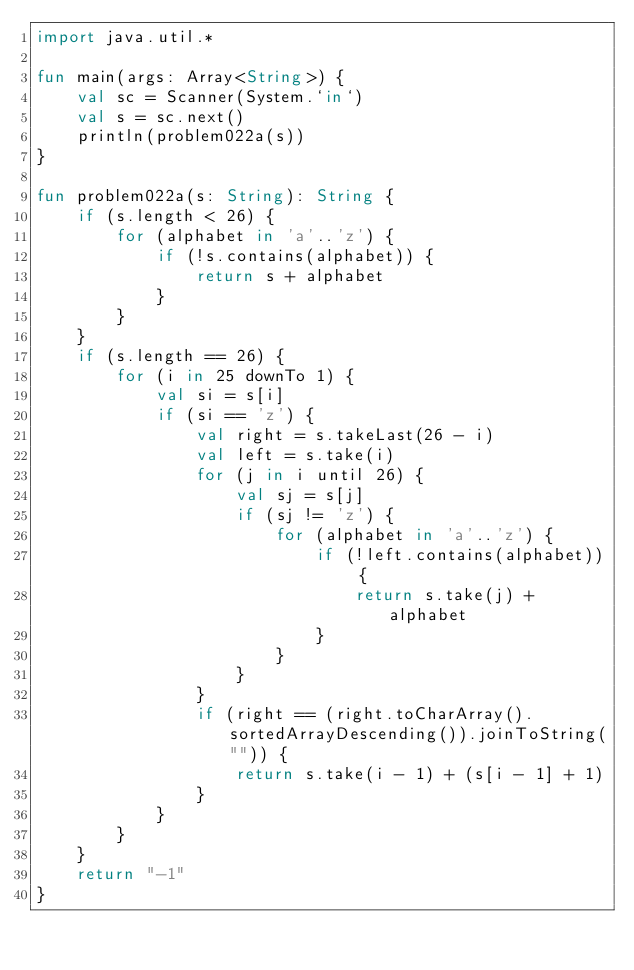<code> <loc_0><loc_0><loc_500><loc_500><_Kotlin_>import java.util.*

fun main(args: Array<String>) {
    val sc = Scanner(System.`in`)
    val s = sc.next()
    println(problem022a(s))
}

fun problem022a(s: String): String {
    if (s.length < 26) {
        for (alphabet in 'a'..'z') {
            if (!s.contains(alphabet)) {
                return s + alphabet
            }
        }
    }
    if (s.length == 26) {
        for (i in 25 downTo 1) {
            val si = s[i]
            if (si == 'z') {
                val right = s.takeLast(26 - i)
                val left = s.take(i)
                for (j in i until 26) {
                    val sj = s[j]
                    if (sj != 'z') {
                        for (alphabet in 'a'..'z') {
                            if (!left.contains(alphabet)) {
                                return s.take(j) + alphabet
                            }
                        }
                    }
                }
                if (right == (right.toCharArray().sortedArrayDescending()).joinToString("")) {
                    return s.take(i - 1) + (s[i - 1] + 1)
                }
            }
        }
    }
    return "-1"
}</code> 